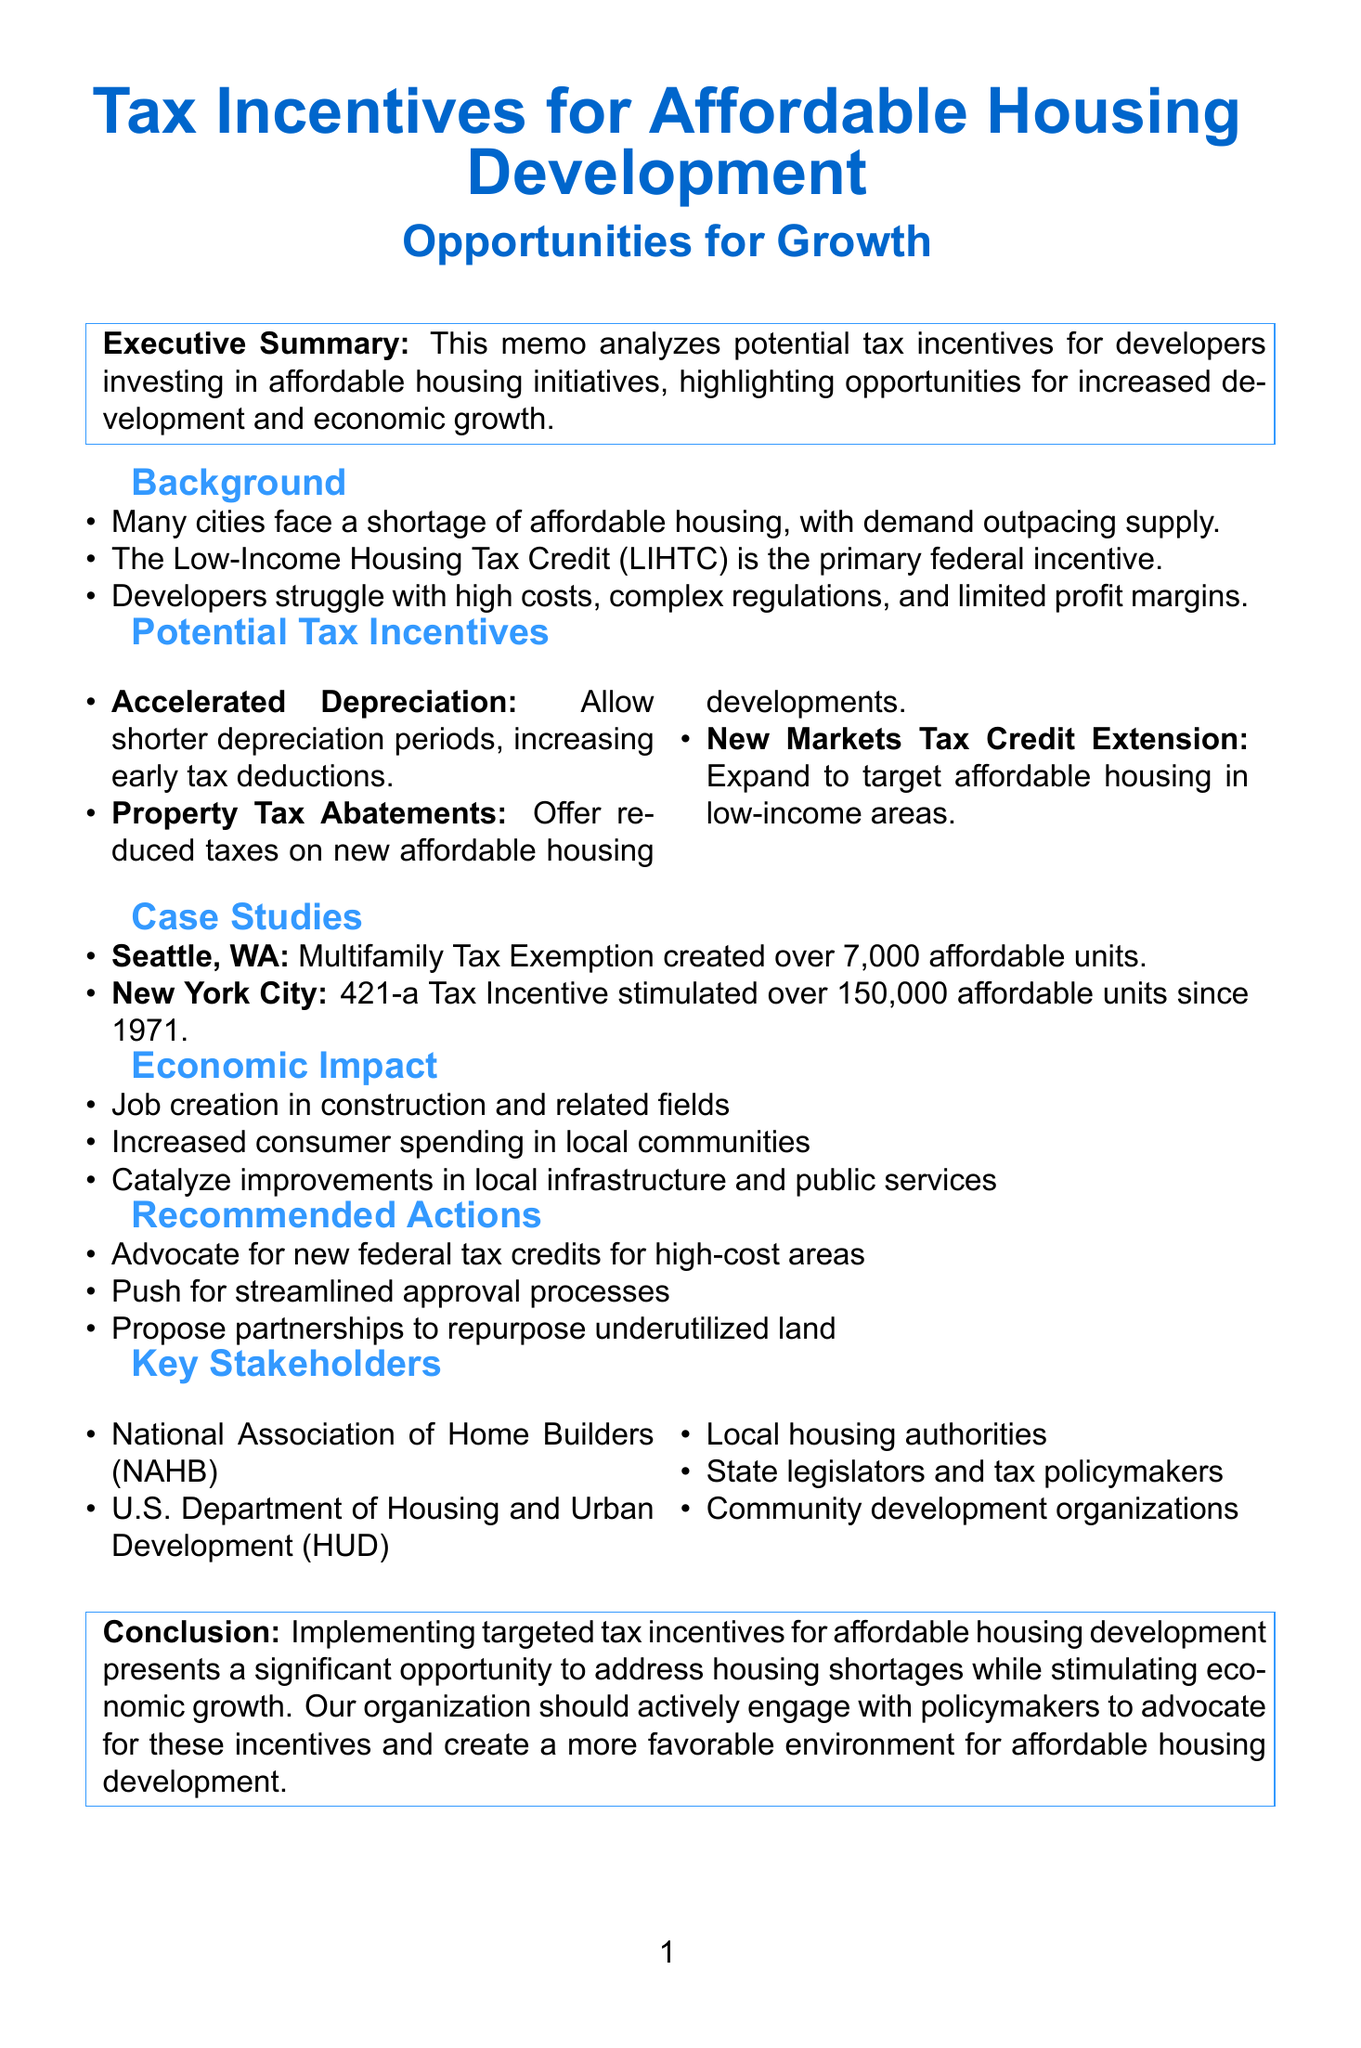what is the title of the memo? The title of the memo is stated at the beginning and summarizes the focus on tax incentives for affordable housing development.
Answer: Tax Incentives for Affordable Housing Development: Opportunities for Growth what is one existing incentive for affordable housing development? The document mentions the Low-Income Housing Tax Credit (LIHTC) as a federal incentive currently in place.
Answer: Low-Income Housing Tax Credit (LIHTC) how many affordable units were created in Seattle under the Multifamily Tax Exemption? The results from the Seattle case study indicate the total number of affordable units created.
Answer: over 7,000 what is a potential impact of property tax abatements? The document explains the financial benefits related to property tax abatements for developers.
Answer: Lower operating costs which federal tax credit is recommended to be introduced? The recommended action includes advocating for a new federal tax credit targeting specific areas.
Answer: new federal tax credit how can increasing affordable housing development affect local economies? The memo discusses various economic impacts from affordable housing, including increased consumer spending.
Answer: Increased consumer spending what year was the 421-a Tax Incentive introduced? The New York City case study specifies the year that the 421-a Tax Incentive was introduced.
Answer: 1971 name one key stakeholder mentioned in the memo. The memo lists several key stakeholders that are involved in affordable housing development.
Answer: National Association of Home Builders (NAHB) 